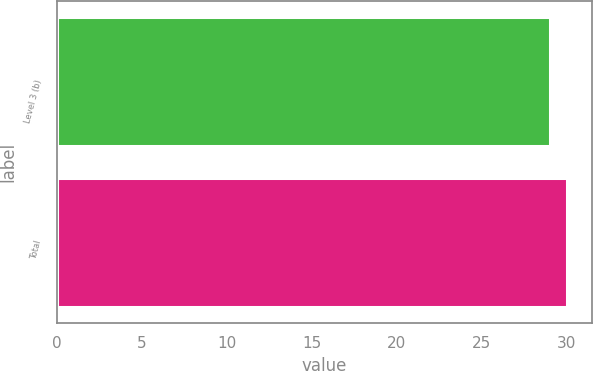<chart> <loc_0><loc_0><loc_500><loc_500><bar_chart><fcel>Level 3 (b)<fcel>Total<nl><fcel>29<fcel>30<nl></chart> 